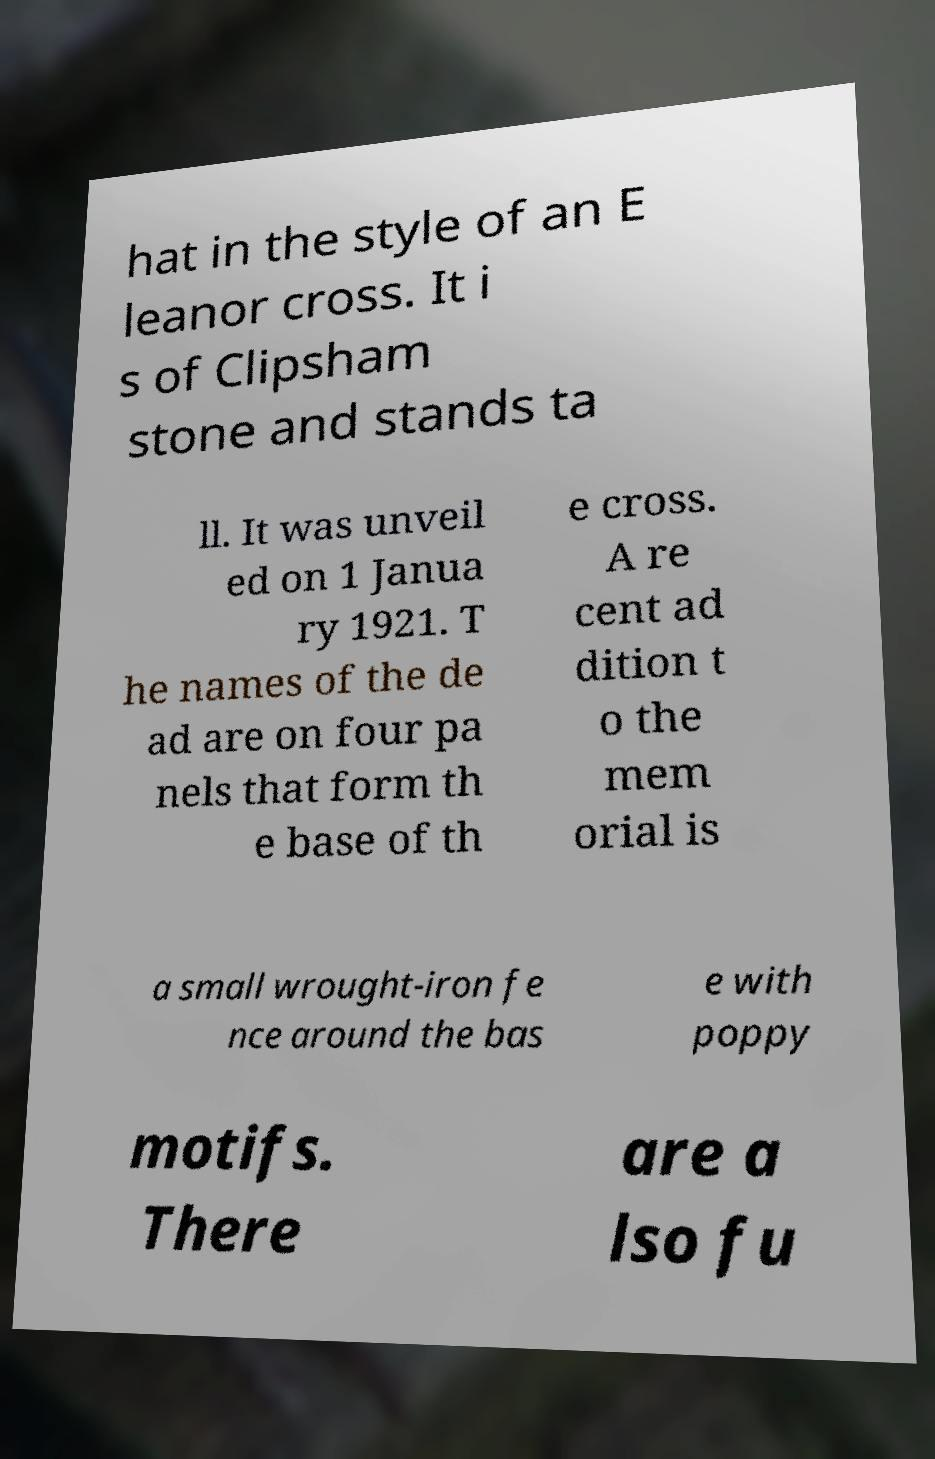What messages or text are displayed in this image? I need them in a readable, typed format. hat in the style of an E leanor cross. It i s of Clipsham stone and stands ta ll. It was unveil ed on 1 Janua ry 1921. T he names of the de ad are on four pa nels that form th e base of th e cross. A re cent ad dition t o the mem orial is a small wrought-iron fe nce around the bas e with poppy motifs. There are a lso fu 